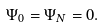<formula> <loc_0><loc_0><loc_500><loc_500>\Psi _ { 0 } = \Psi _ { N } = 0 .</formula> 